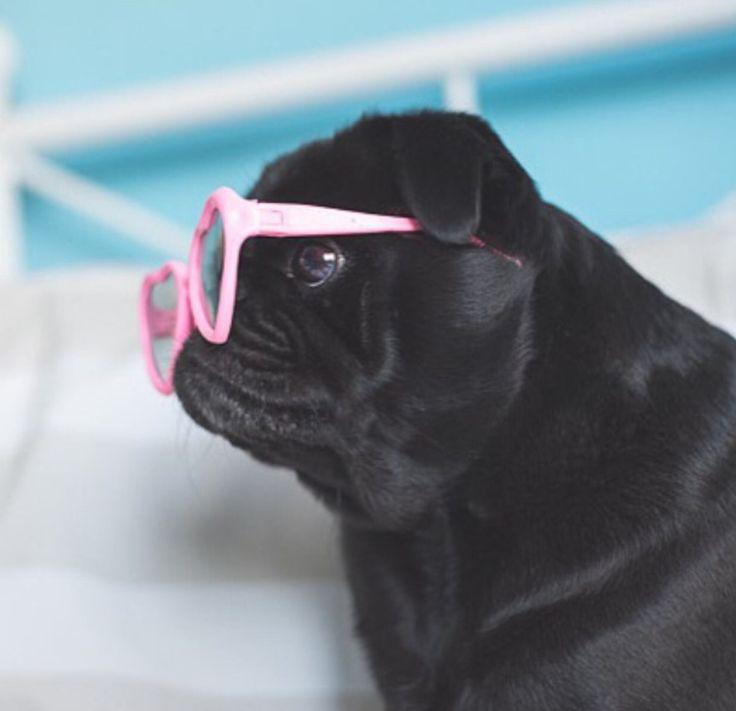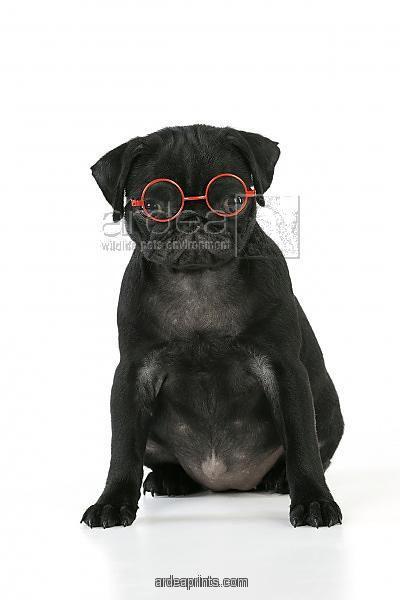The first image is the image on the left, the second image is the image on the right. Considering the images on both sides, is "The pug in the right image faces the camera head-on and wears glasses with round lenses." valid? Answer yes or no. Yes. The first image is the image on the left, the second image is the image on the right. Examine the images to the left and right. Is the description "The pug on the right is wearing glasses with round frames." accurate? Answer yes or no. Yes. 